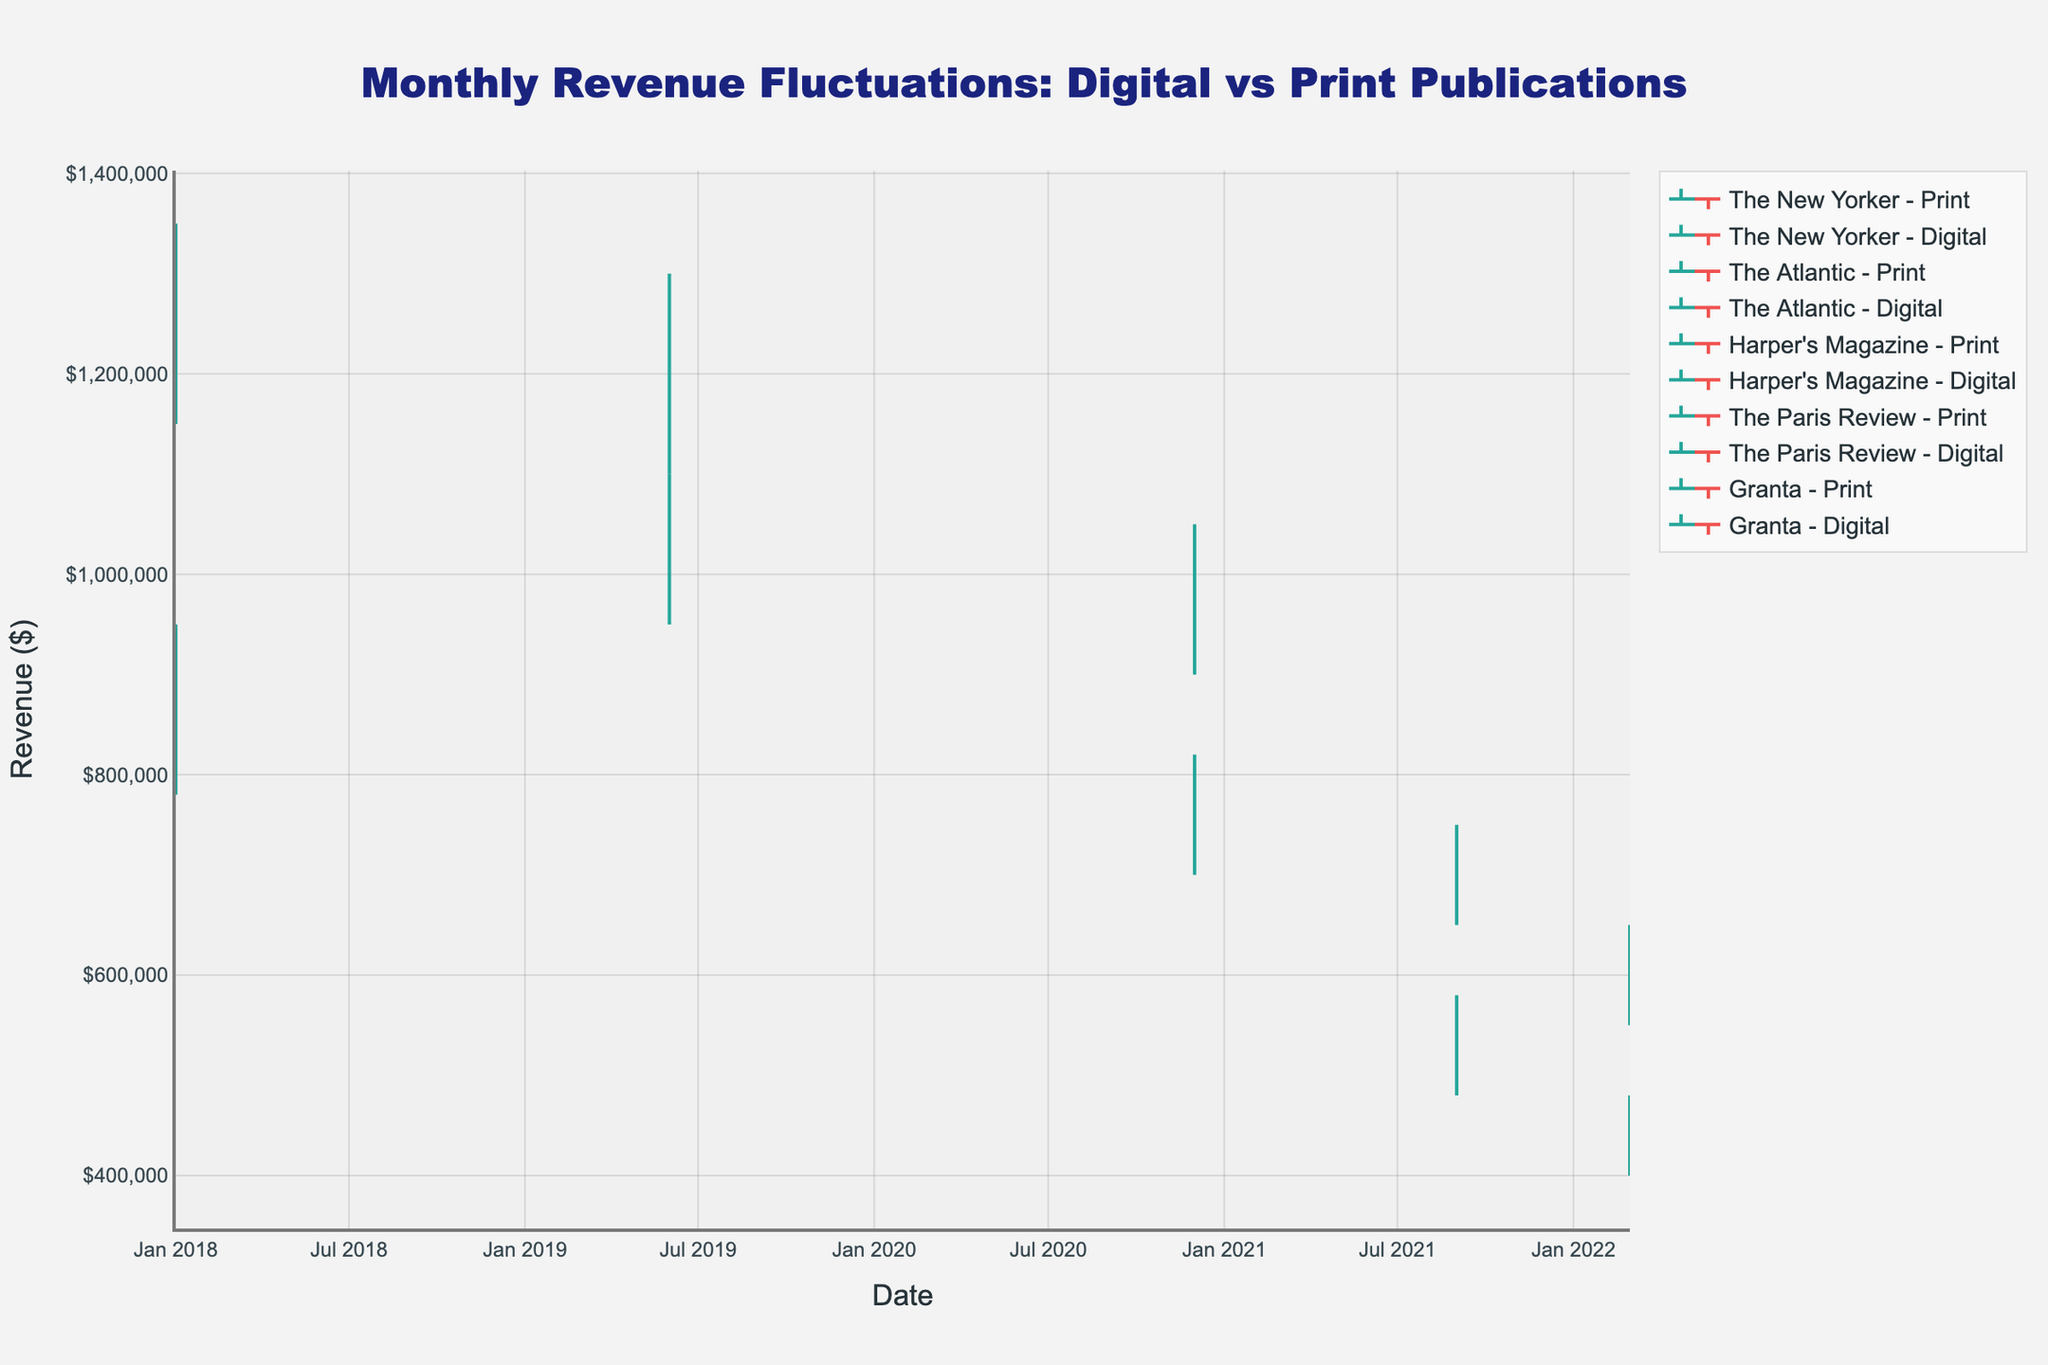What is the title of the plot? The title is located at the top of the plot, centered and usually larger in font size. It summarizes the content and purpose of the plot.
Answer: Monthly Revenue Fluctuations: Digital vs Print Publications How many unique publications are represented in the plot? To determine the unique publications, count the distinct names listed in the legend or identify them from the plot itself if labeled.
Answer: 4 (The New Yorker, The Atlantic, Harper's Magazine, The Paris Review, Granta) Which publication had the highest recorded monthly revenue in digital format? Identify the digital format traces in the chart and compare their highest points (high values) to find which one is the highest.
Answer: The Atlantic What is the difference between the highest and lowest revenue for Harper's Magazine in print format? Look at Harper's Magazine in print format, identify the 'High' and 'Low' values, and calculate their difference, 820000 - 700000.
Answer: $120,000 Which publication saw a higher closing revenue in digital format compared to print in March 2022? Identify the closing revenue for both print and digital formats of each publication in March 2022 and compare them.
Answer: Granta What is the general trend for The New Yorker’s print revenue from January 2018? Examine the open and close values for The New Yorker in print format in January 2018. Determine whether there was an increase or decrease from open to close.
Answer: Increase Considering all publications, which format (print or digital) generally has higher fluctuations in revenue? For each publication, compare the difference between the high and low values for both print and digital formats and determine which format has larger differences more frequently.
Answer: Digital What is the average closing revenue for The Atlantic in both print and digital formats as recorded? Add the closing revenue for The Atlantic in both formats and divide by 2: (1050000 + 1280000) / 2.
Answer: $1,165,000 How does the revenue trend of print publications compare to digital publications over five years? Observe the slopes and patterns of both print and digital traces over the five-year period to determine whether print shows more stability, decline, or growth compared to digital.
Answer: Digital shows more growth and higher fluctuations Did The Paris Review have a higher opening revenue in print or digital format in September 2021? Compare the opening values for The Paris Review in both formats as of September 2021.
Answer: Digital 